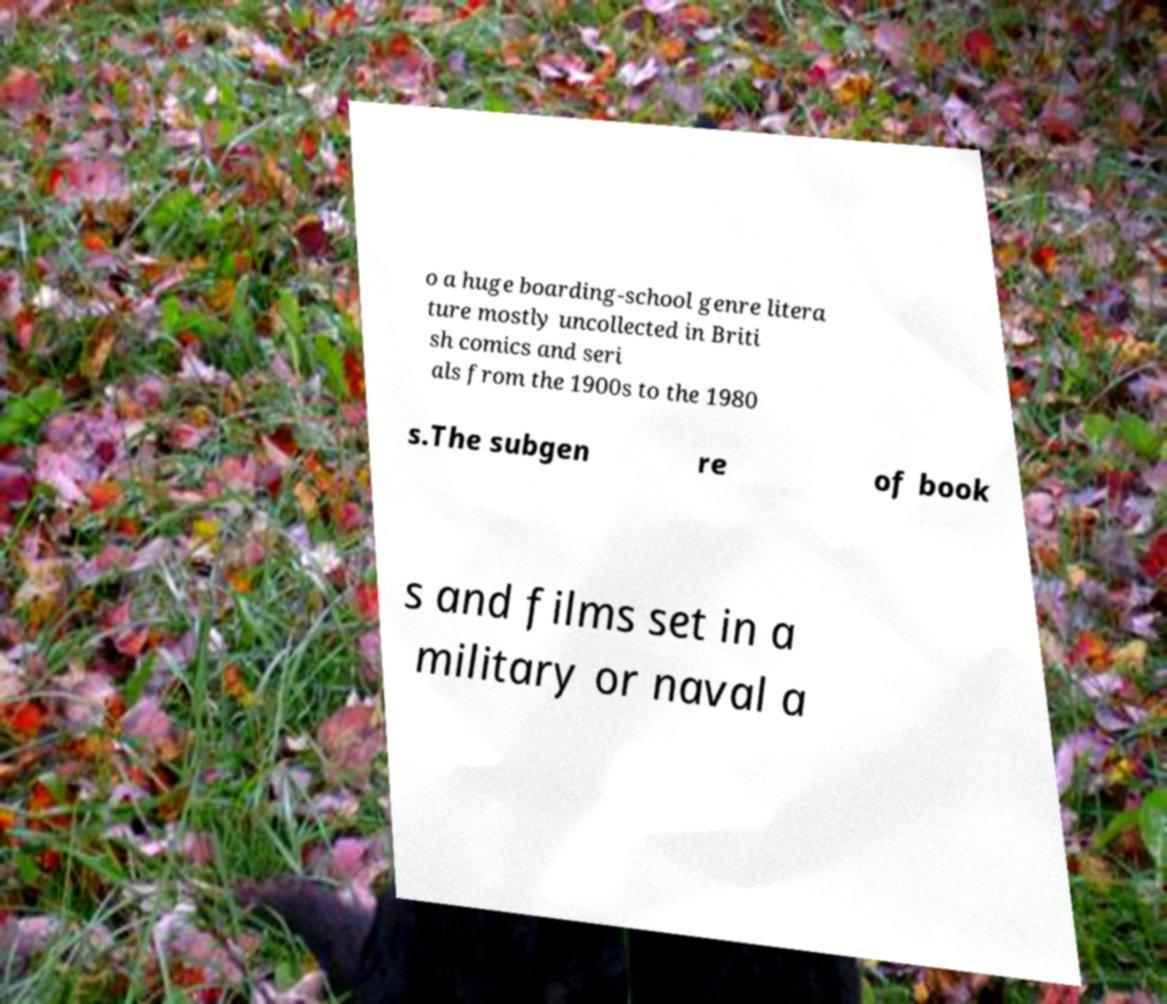Can you read and provide the text displayed in the image?This photo seems to have some interesting text. Can you extract and type it out for me? o a huge boarding-school genre litera ture mostly uncollected in Briti sh comics and seri als from the 1900s to the 1980 s.The subgen re of book s and films set in a military or naval a 